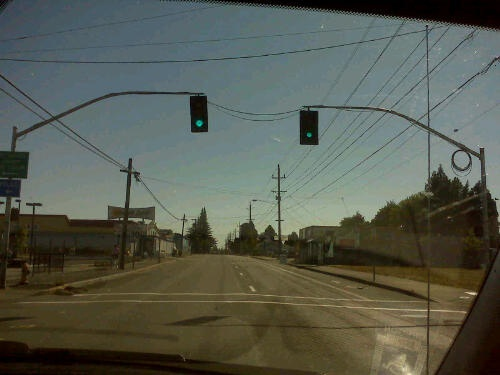Describe the objects in this image and their specific colors. I can see traffic light in black, gray, and teal tones, traffic light in black, gray, and teal tones, people in black, darkgreen, and gray tones, and fire hydrant in black and maroon tones in this image. 